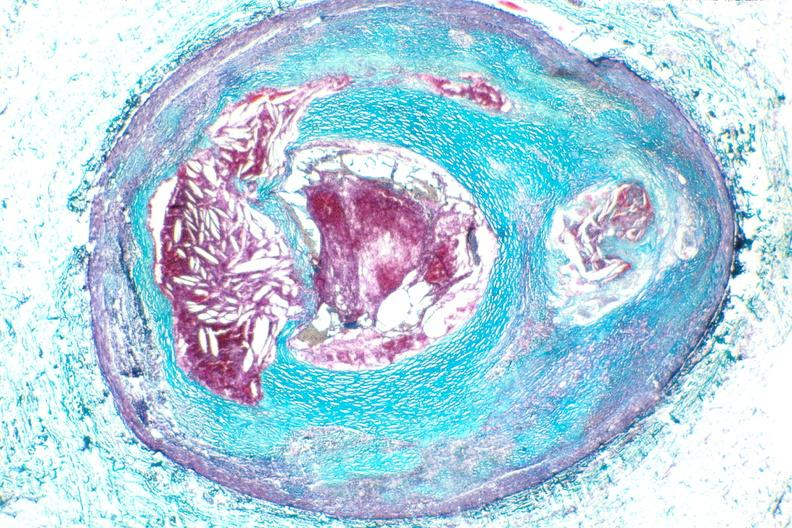does this image show right coronary artery, atherosclerosis and acute thrombus?
Answer the question using a single word or phrase. Yes 